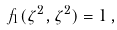Convert formula to latex. <formula><loc_0><loc_0><loc_500><loc_500>f _ { 1 } ( \zeta ^ { 2 } , \zeta ^ { 2 } ) = 1 \, ,</formula> 